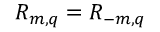<formula> <loc_0><loc_0><loc_500><loc_500>R _ { m , q } = R _ { - m , q }</formula> 